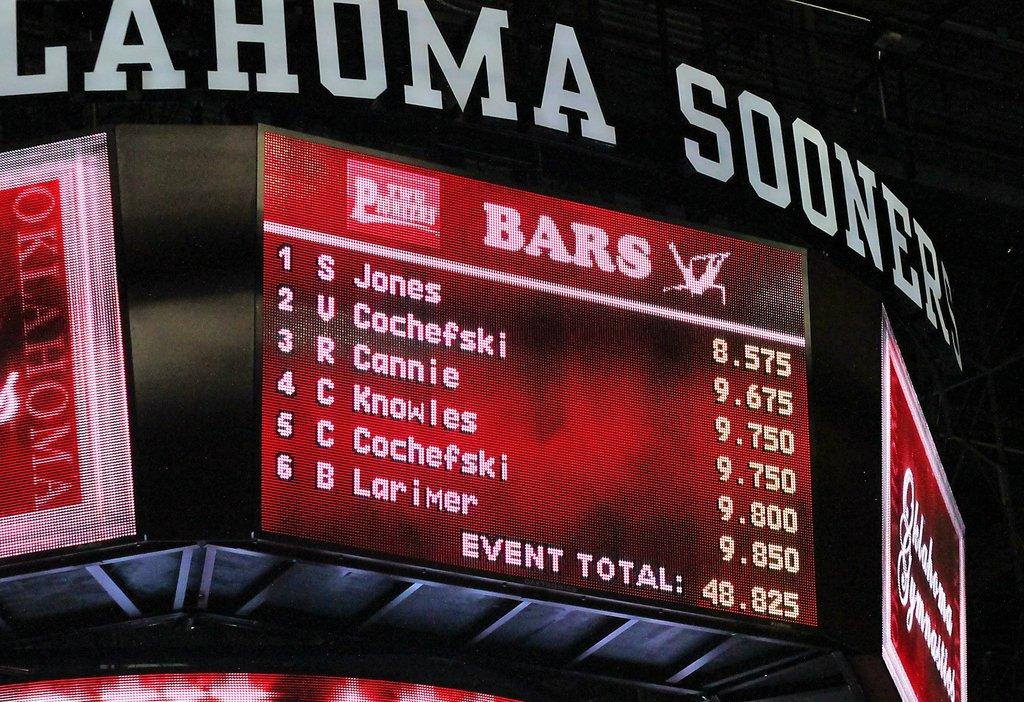<image>
Describe the image concisely. A jumbo tron featuring the names of several players on it. 